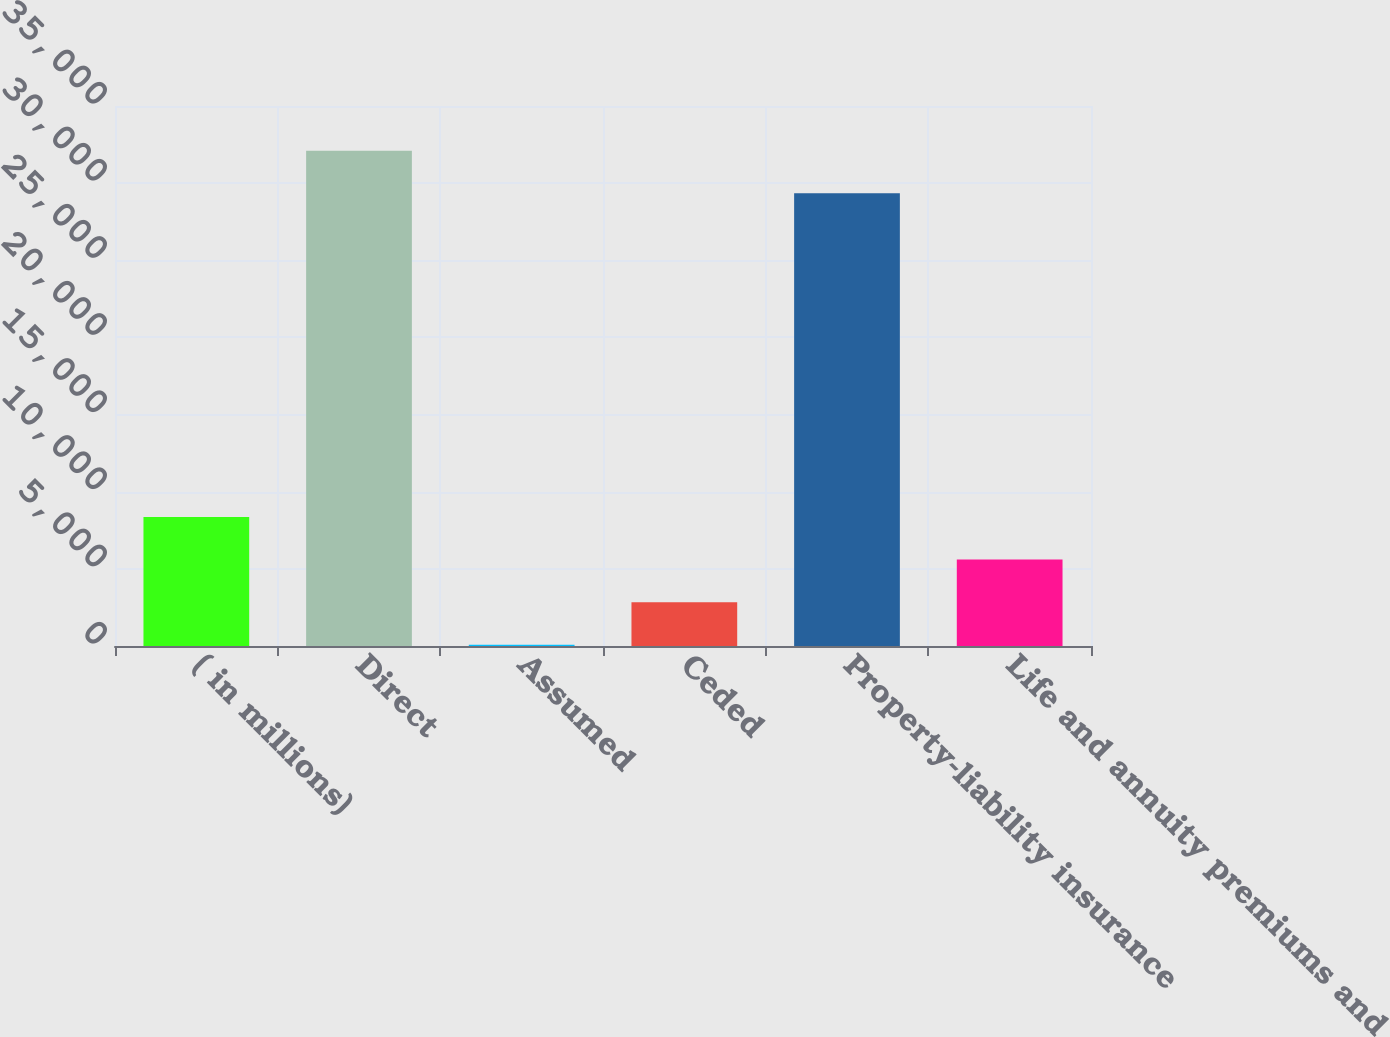Convert chart. <chart><loc_0><loc_0><loc_500><loc_500><bar_chart><fcel>( in millions)<fcel>Direct<fcel>Assumed<fcel>Ceded<fcel>Property-liability insurance<fcel>Life and annuity premiums and<nl><fcel>8359.6<fcel>32100.4<fcel>85<fcel>2843.2<fcel>29342.2<fcel>5601.4<nl></chart> 